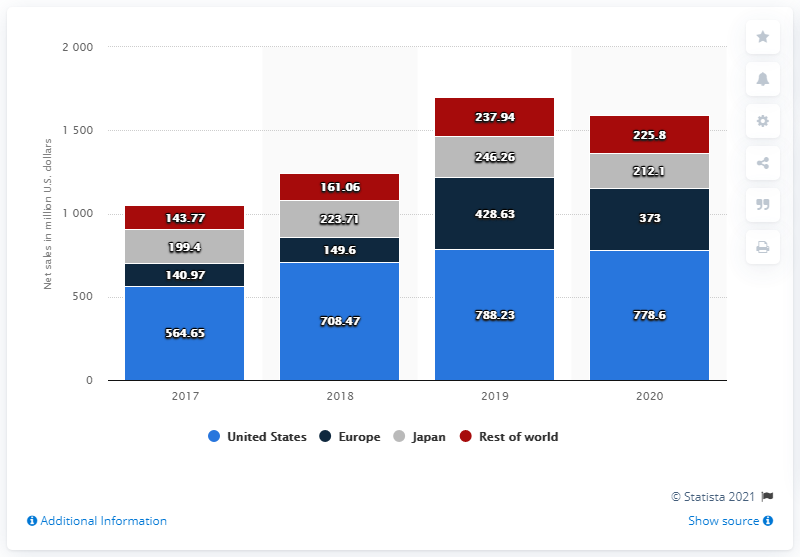Specify some key components in this picture. In 2020, the net sales of Callaway Golf in the United States were 778.6 million dollars. 